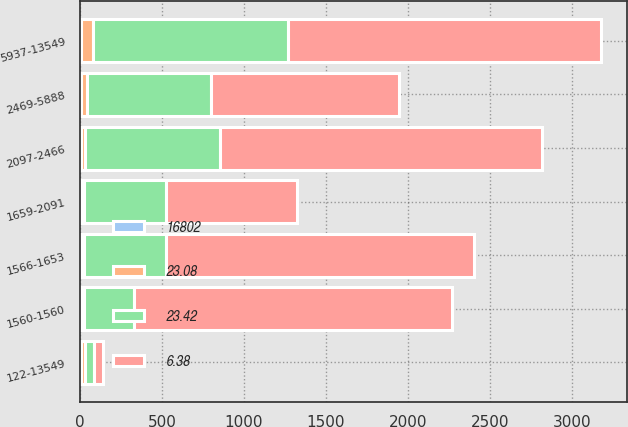Convert chart. <chart><loc_0><loc_0><loc_500><loc_500><stacked_bar_chart><ecel><fcel>1560-1560<fcel>1566-1653<fcel>1659-2091<fcel>2097-2466<fcel>2469-5888<fcel>5937-13549<fcel>122-13549<nl><fcel>6.38<fcel>1938<fcel>1873<fcel>799<fcel>1962<fcel>1146<fcel>1910<fcel>55.84<nl><fcel>16802<fcel>9.05<fcel>8.45<fcel>6.89<fcel>7.89<fcel>7.24<fcel>6.89<fcel>6.38<nl><fcel>23.08<fcel>15.6<fcel>15.95<fcel>18.78<fcel>24.47<fcel>38.62<fcel>73.06<fcel>23.42<nl><fcel>23.42<fcel>307<fcel>503<fcel>501<fcel>823<fcel>751<fcel>1187<fcel>55.84<nl></chart> 